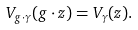<formula> <loc_0><loc_0><loc_500><loc_500>V _ { g \cdot \gamma } ( g \cdot z ) = V _ { \gamma } ( z ) .</formula> 